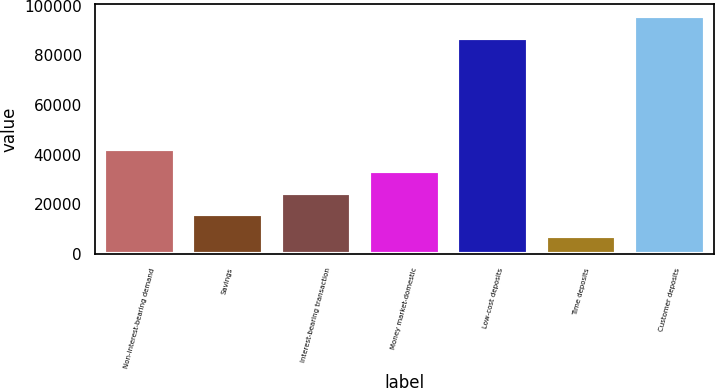<chart> <loc_0><loc_0><loc_500><loc_500><bar_chart><fcel>Non-interest-bearing demand<fcel>Savings<fcel>Interest-bearing transaction<fcel>Money market-domestic<fcel>Low-cost deposits<fcel>Time deposits<fcel>Customer deposits<nl><fcel>42214.8<fcel>16076.7<fcel>24789.4<fcel>33502.1<fcel>87127<fcel>7364<fcel>95839.7<nl></chart> 